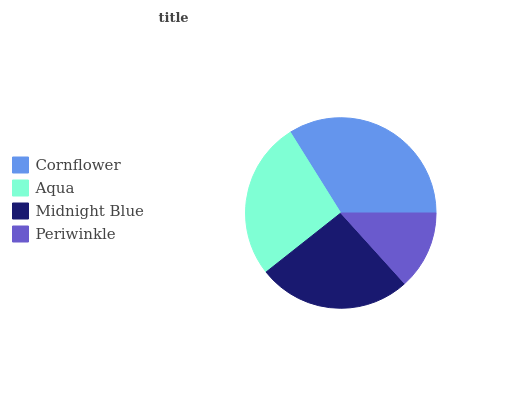Is Periwinkle the minimum?
Answer yes or no. Yes. Is Cornflower the maximum?
Answer yes or no. Yes. Is Aqua the minimum?
Answer yes or no. No. Is Aqua the maximum?
Answer yes or no. No. Is Cornflower greater than Aqua?
Answer yes or no. Yes. Is Aqua less than Cornflower?
Answer yes or no. Yes. Is Aqua greater than Cornflower?
Answer yes or no. No. Is Cornflower less than Aqua?
Answer yes or no. No. Is Aqua the high median?
Answer yes or no. Yes. Is Midnight Blue the low median?
Answer yes or no. Yes. Is Midnight Blue the high median?
Answer yes or no. No. Is Periwinkle the low median?
Answer yes or no. No. 